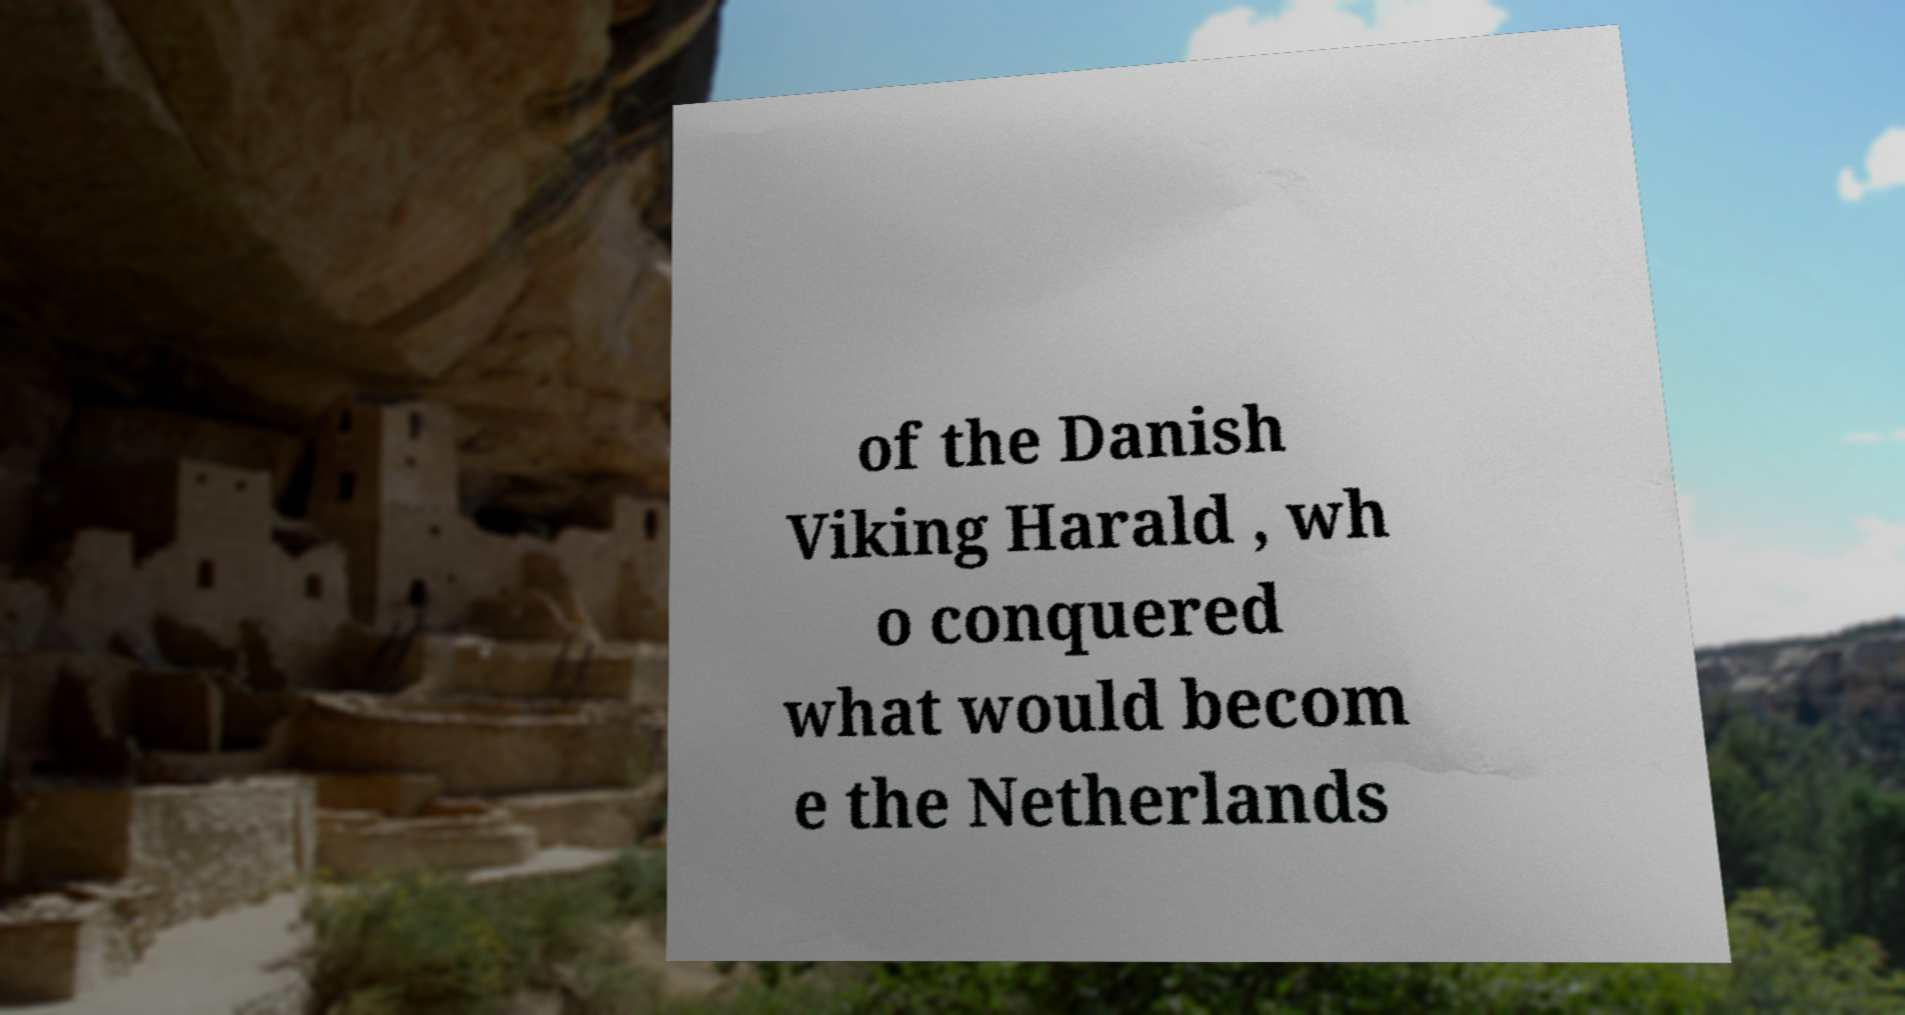Could you assist in decoding the text presented in this image and type it out clearly? of the Danish Viking Harald , wh o conquered what would becom e the Netherlands 